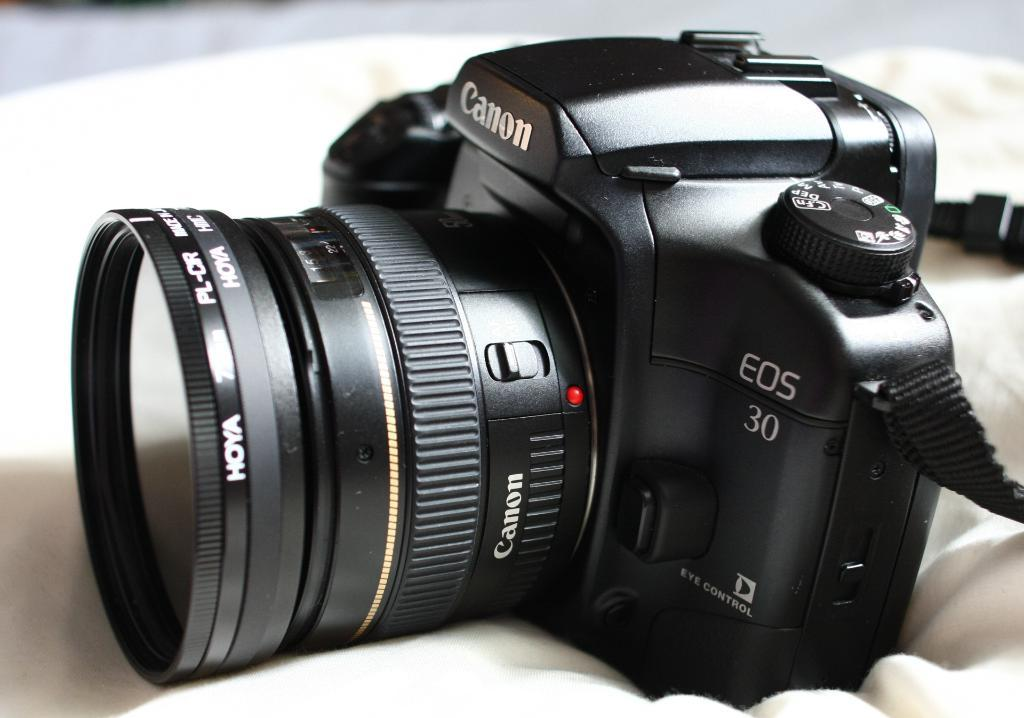What is the main subject of the image? The main subject of the image is not specified, but there is an image present. What color is the camera in the image? The camera in the image is black. What type of material is at the bottom of the image? There is a white cloth at the bottom of the image. What type of stone can be seen at the top of the image? There is no stone present in the image; it only contains an image, a black camera, and a white cloth at the bottom. What time of day is depicted in the image? The time of day is not specified in the image, as it only contains an image, a black camera, and a white cloth at the bottom. 